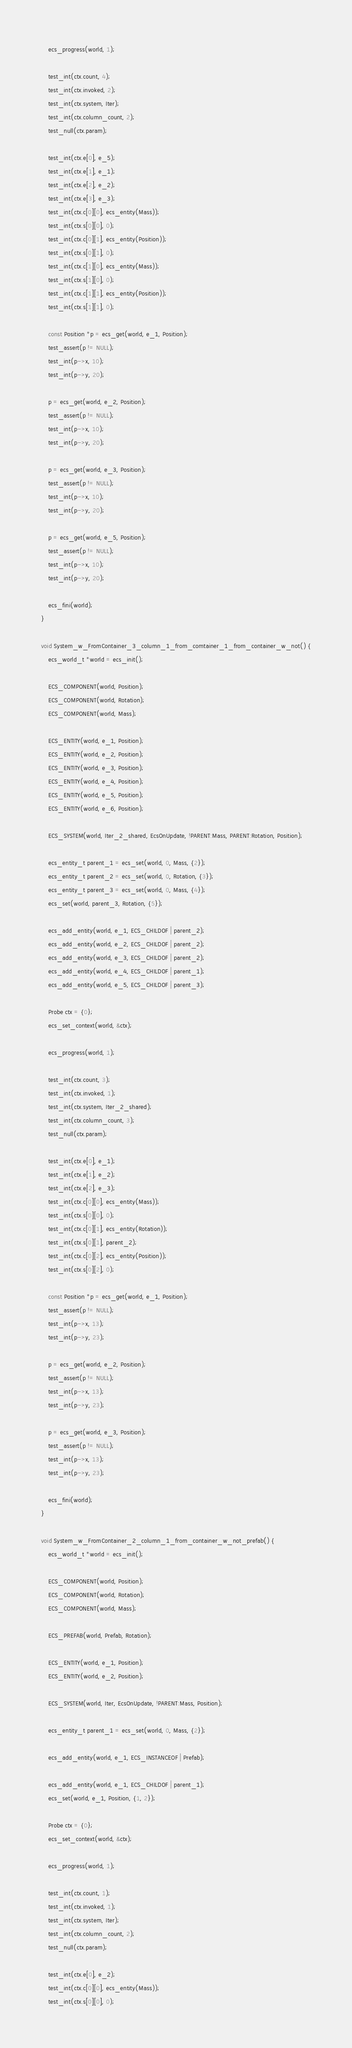<code> <loc_0><loc_0><loc_500><loc_500><_C_>    ecs_progress(world, 1);

    test_int(ctx.count, 4);
    test_int(ctx.invoked, 2);
    test_int(ctx.system, Iter);
    test_int(ctx.column_count, 2);
    test_null(ctx.param);

    test_int(ctx.e[0], e_5);
    test_int(ctx.e[1], e_1);
    test_int(ctx.e[2], e_2);
    test_int(ctx.e[3], e_3);
    test_int(ctx.c[0][0], ecs_entity(Mass));
    test_int(ctx.s[0][0], 0);
    test_int(ctx.c[0][1], ecs_entity(Position));
    test_int(ctx.s[0][1], 0);
    test_int(ctx.c[1][0], ecs_entity(Mass));
    test_int(ctx.s[1][0], 0);
    test_int(ctx.c[1][1], ecs_entity(Position));
    test_int(ctx.s[1][1], 0);

    const Position *p = ecs_get(world, e_1, Position);
    test_assert(p != NULL);
    test_int(p->x, 10);
    test_int(p->y, 20);

    p = ecs_get(world, e_2, Position);
    test_assert(p != NULL);
    test_int(p->x, 10);
    test_int(p->y, 20);

    p = ecs_get(world, e_3, Position);
    test_assert(p != NULL);
    test_int(p->x, 10);
    test_int(p->y, 20);

    p = ecs_get(world, e_5, Position);
    test_assert(p != NULL);
    test_int(p->x, 10);
    test_int(p->y, 20);

    ecs_fini(world);
}

void System_w_FromContainer_3_column_1_from_comtainer_1_from_container_w_not() {
    ecs_world_t *world = ecs_init();

    ECS_COMPONENT(world, Position);
    ECS_COMPONENT(world, Rotation);
    ECS_COMPONENT(world, Mass);

    ECS_ENTITY(world, e_1, Position);
    ECS_ENTITY(world, e_2, Position);
    ECS_ENTITY(world, e_3, Position);
    ECS_ENTITY(world, e_4, Position);
    ECS_ENTITY(world, e_5, Position);
    ECS_ENTITY(world, e_6, Position);

    ECS_SYSTEM(world, Iter_2_shared, EcsOnUpdate, !PARENT:Mass, PARENT:Rotation, Position);

    ecs_entity_t parent_1 = ecs_set(world, 0, Mass, {2});
    ecs_entity_t parent_2 = ecs_set(world, 0, Rotation, {3});
    ecs_entity_t parent_3 = ecs_set(world, 0, Mass, {4});
    ecs_set(world, parent_3, Rotation, {5});

    ecs_add_entity(world, e_1, ECS_CHILDOF | parent_2);
    ecs_add_entity(world, e_2, ECS_CHILDOF | parent_2);
    ecs_add_entity(world, e_3, ECS_CHILDOF | parent_2);
    ecs_add_entity(world, e_4, ECS_CHILDOF | parent_1);
    ecs_add_entity(world, e_5, ECS_CHILDOF | parent_3);

    Probe ctx = {0};
    ecs_set_context(world, &ctx);

    ecs_progress(world, 1);

    test_int(ctx.count, 3);
    test_int(ctx.invoked, 1);
    test_int(ctx.system, Iter_2_shared);
    test_int(ctx.column_count, 3);
    test_null(ctx.param);

    test_int(ctx.e[0], e_1);
    test_int(ctx.e[1], e_2);
    test_int(ctx.e[2], e_3);
    test_int(ctx.c[0][0], ecs_entity(Mass));
    test_int(ctx.s[0][0], 0);
    test_int(ctx.c[0][1], ecs_entity(Rotation));
    test_int(ctx.s[0][1], parent_2);
    test_int(ctx.c[0][2], ecs_entity(Position));
    test_int(ctx.s[0][2], 0);

    const Position *p = ecs_get(world, e_1, Position);
    test_assert(p != NULL);
    test_int(p->x, 13);
    test_int(p->y, 23);

    p = ecs_get(world, e_2, Position);
    test_assert(p != NULL);
    test_int(p->x, 13);
    test_int(p->y, 23);

    p = ecs_get(world, e_3, Position);
    test_assert(p != NULL);
    test_int(p->x, 13);
    test_int(p->y, 23);

    ecs_fini(world);
}

void System_w_FromContainer_2_column_1_from_container_w_not_prefab() {
    ecs_world_t *world = ecs_init();

    ECS_COMPONENT(world, Position);
    ECS_COMPONENT(world, Rotation);
    ECS_COMPONENT(world, Mass);

    ECS_PREFAB(world, Prefab, Rotation);

    ECS_ENTITY(world, e_1, Position);
    ECS_ENTITY(world, e_2, Position);

    ECS_SYSTEM(world, Iter, EcsOnUpdate, !PARENT:Mass, Position);

    ecs_entity_t parent_1 = ecs_set(world, 0, Mass, {2});

    ecs_add_entity(world, e_1, ECS_INSTANCEOF | Prefab);

    ecs_add_entity(world, e_1, ECS_CHILDOF | parent_1);
    ecs_set(world, e_1, Position, {1, 2});

    Probe ctx = {0};
    ecs_set_context(world, &ctx);

    ecs_progress(world, 1);

    test_int(ctx.count, 1);
    test_int(ctx.invoked, 1);
    test_int(ctx.system, Iter);
    test_int(ctx.column_count, 2);
    test_null(ctx.param);

    test_int(ctx.e[0], e_2);
    test_int(ctx.c[0][0], ecs_entity(Mass));
    test_int(ctx.s[0][0], 0);</code> 